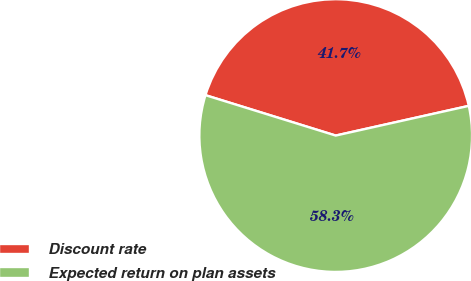<chart> <loc_0><loc_0><loc_500><loc_500><pie_chart><fcel>Discount rate<fcel>Expected return on plan assets<nl><fcel>41.72%<fcel>58.28%<nl></chart> 